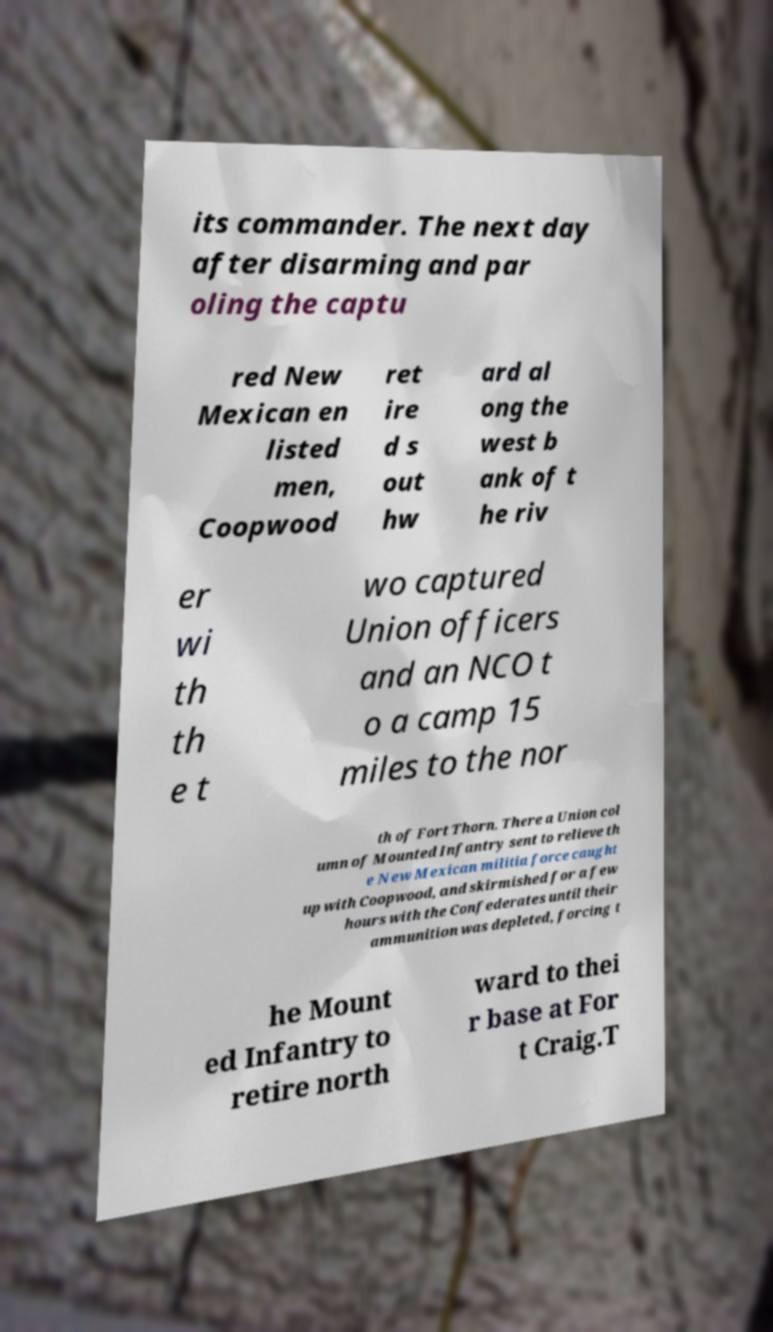What messages or text are displayed in this image? I need them in a readable, typed format. its commander. The next day after disarming and par oling the captu red New Mexican en listed men, Coopwood ret ire d s out hw ard al ong the west b ank of t he riv er wi th th e t wo captured Union officers and an NCO t o a camp 15 miles to the nor th of Fort Thorn. There a Union col umn of Mounted Infantry sent to relieve th e New Mexican militia force caught up with Coopwood, and skirmished for a few hours with the Confederates until their ammunition was depleted, forcing t he Mount ed Infantry to retire north ward to thei r base at For t Craig.T 